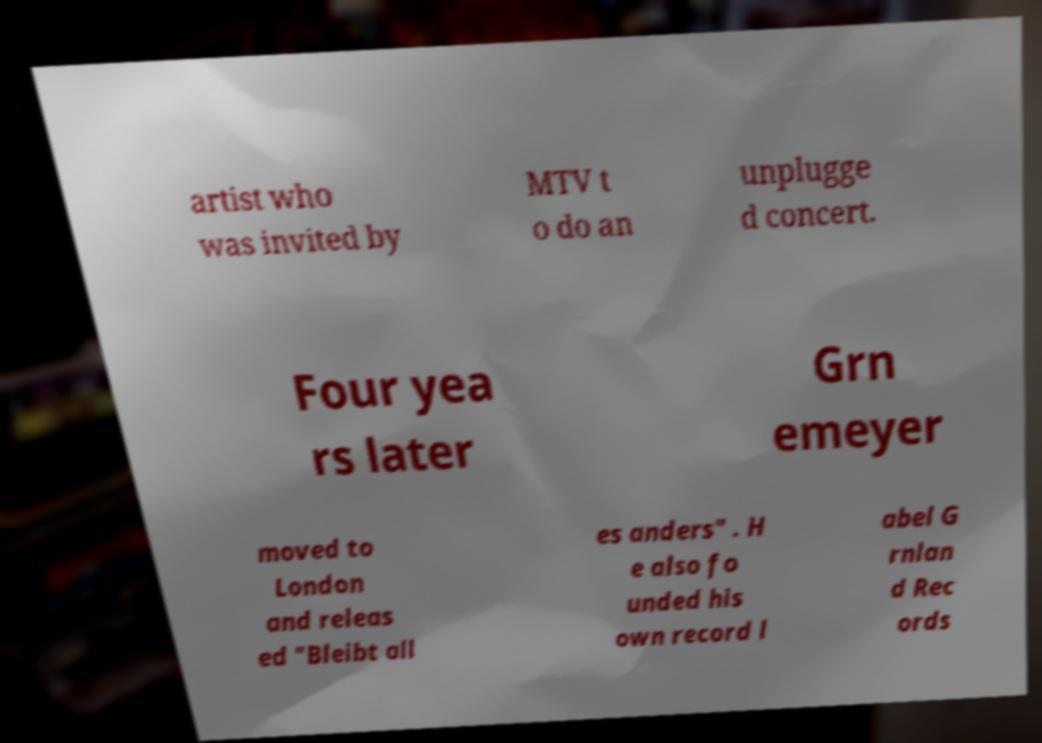Please read and relay the text visible in this image. What does it say? artist who was invited by MTV t o do an unplugge d concert. Four yea rs later Grn emeyer moved to London and releas ed "Bleibt all es anders" . H e also fo unded his own record l abel G rnlan d Rec ords 